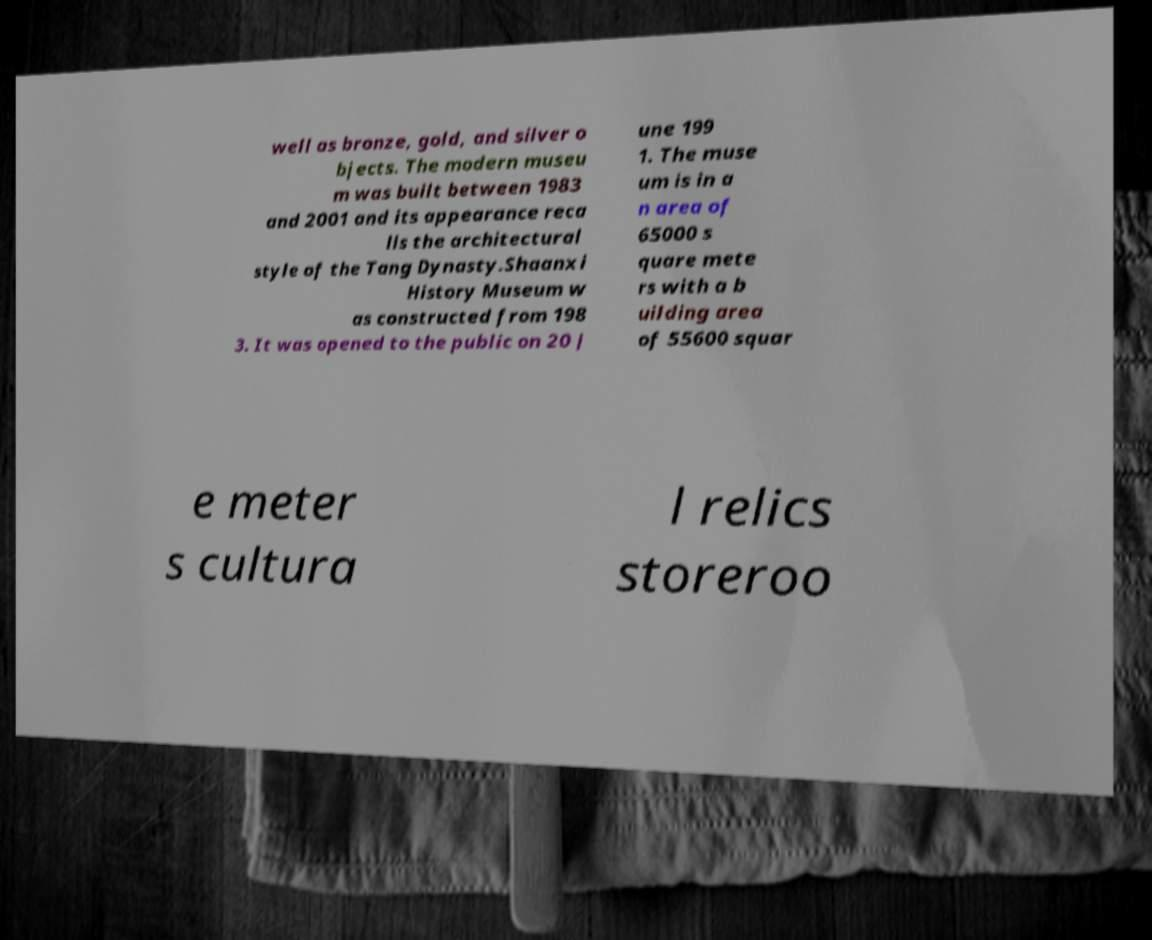Please read and relay the text visible in this image. What does it say? well as bronze, gold, and silver o bjects. The modern museu m was built between 1983 and 2001 and its appearance reca lls the architectural style of the Tang Dynasty.Shaanxi History Museum w as constructed from 198 3. It was opened to the public on 20 J une 199 1. The muse um is in a n area of 65000 s quare mete rs with a b uilding area of 55600 squar e meter s cultura l relics storeroo 